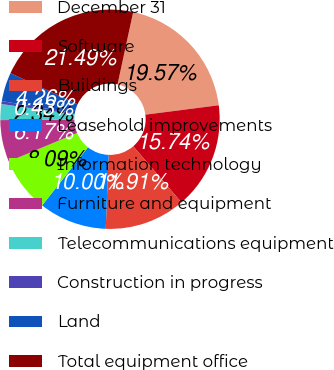Convert chart. <chart><loc_0><loc_0><loc_500><loc_500><pie_chart><fcel>December 31<fcel>Software<fcel>Buildings<fcel>Leasehold improvements<fcel>Information technology<fcel>Furniture and equipment<fcel>Telecommunications equipment<fcel>Construction in progress<fcel>Land<fcel>Total equipment office<nl><fcel>19.57%<fcel>15.74%<fcel>11.91%<fcel>10.0%<fcel>8.09%<fcel>6.17%<fcel>2.34%<fcel>0.43%<fcel>4.26%<fcel>21.49%<nl></chart> 